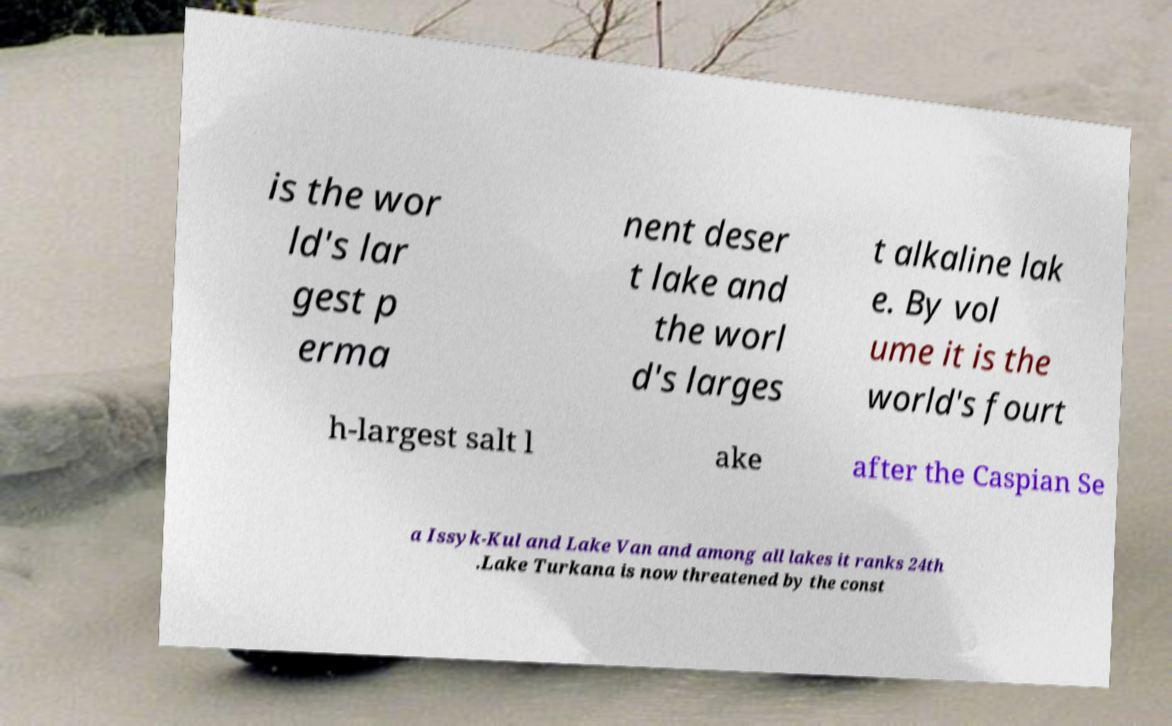Could you assist in decoding the text presented in this image and type it out clearly? is the wor ld's lar gest p erma nent deser t lake and the worl d's larges t alkaline lak e. By vol ume it is the world's fourt h-largest salt l ake after the Caspian Se a Issyk-Kul and Lake Van and among all lakes it ranks 24th .Lake Turkana is now threatened by the const 